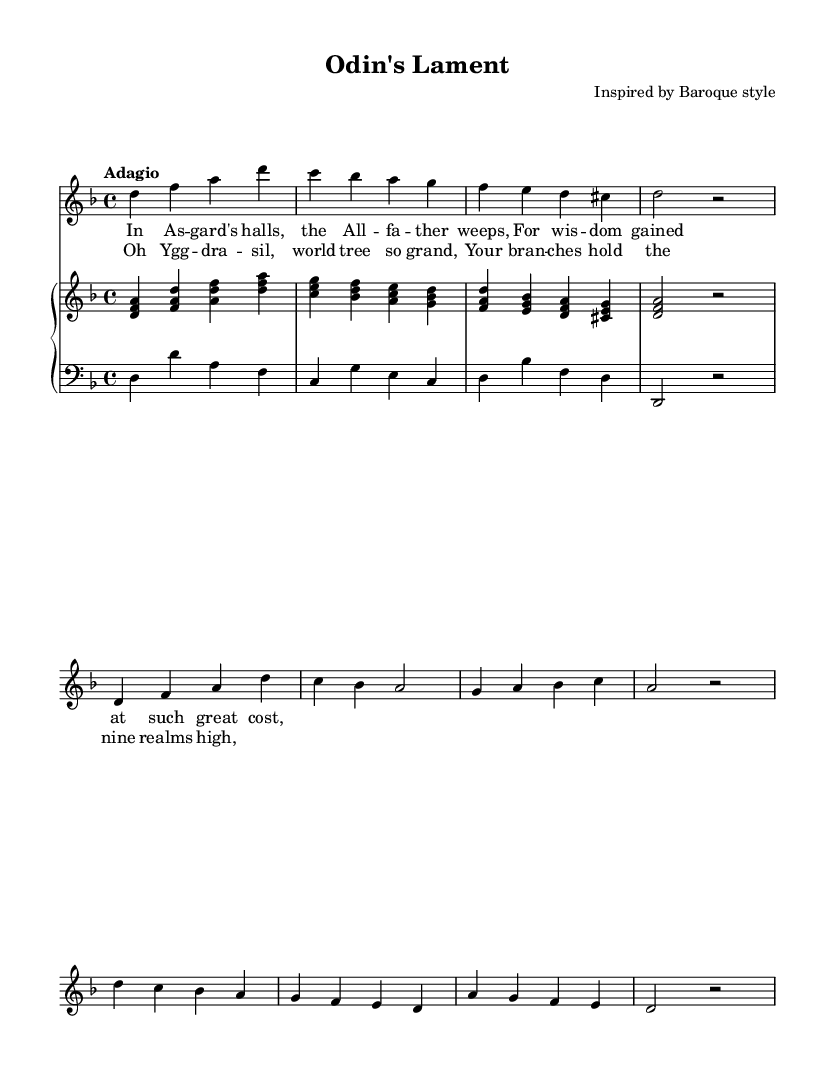What is the key signature of this music? The key signature displayed indicates D minor, which has one flat (B flat) and is the relative minor of F major. You can identify this by looking at the key signature at the beginning of the staff, which shows one flat.
Answer: D minor What is the time signature of this piece? The time signature shown in the top left corner is 4/4, which means there are four beats in each measure and each quarter note receives one beat. This is evident from the notation just after the key signature.
Answer: 4/4 What is the tempo marking of this piece? The tempo marking provided is "Adagio," which denotes a slow tempo. This information can be found above the staff where the tempo indications are usually placed.
Answer: Adagio How many measures are there in the introduction? The introduction consists of four measures, as indicated by the grouping of notes and vertical bar lines that separate the measures. You can count the measures from the beginning of the piece to the first repetition.
Answer: Four Which mythological figure is mentioned in the lyrics? The lyrics mention "Odin," who is a prominent figure in Norse mythology, specifically referred to as the "All-father." This can be found in the text at the start of the verse, which talks about Odin's lament.
Answer: Odin What are the lyrical themes present in the chorus? The chorus centers around "Yggdrasill," the world tree in Norse mythology, reflecting themes of connection between the realms. The lyrics express admiration for this cosmic structure, highlighting its significance in the mythological world. This is observable in the text of the chorus section.
Answer: Yggdrasill What form does the song predominantly follow? The song predominantly follows a verse-chorus form, alternating between verses and refrains, which is a common structure in vocal works, especially in Baroque. The organization of the lyrics into verses and choruses in the score indicates this form.
Answer: Verse-Chorus 